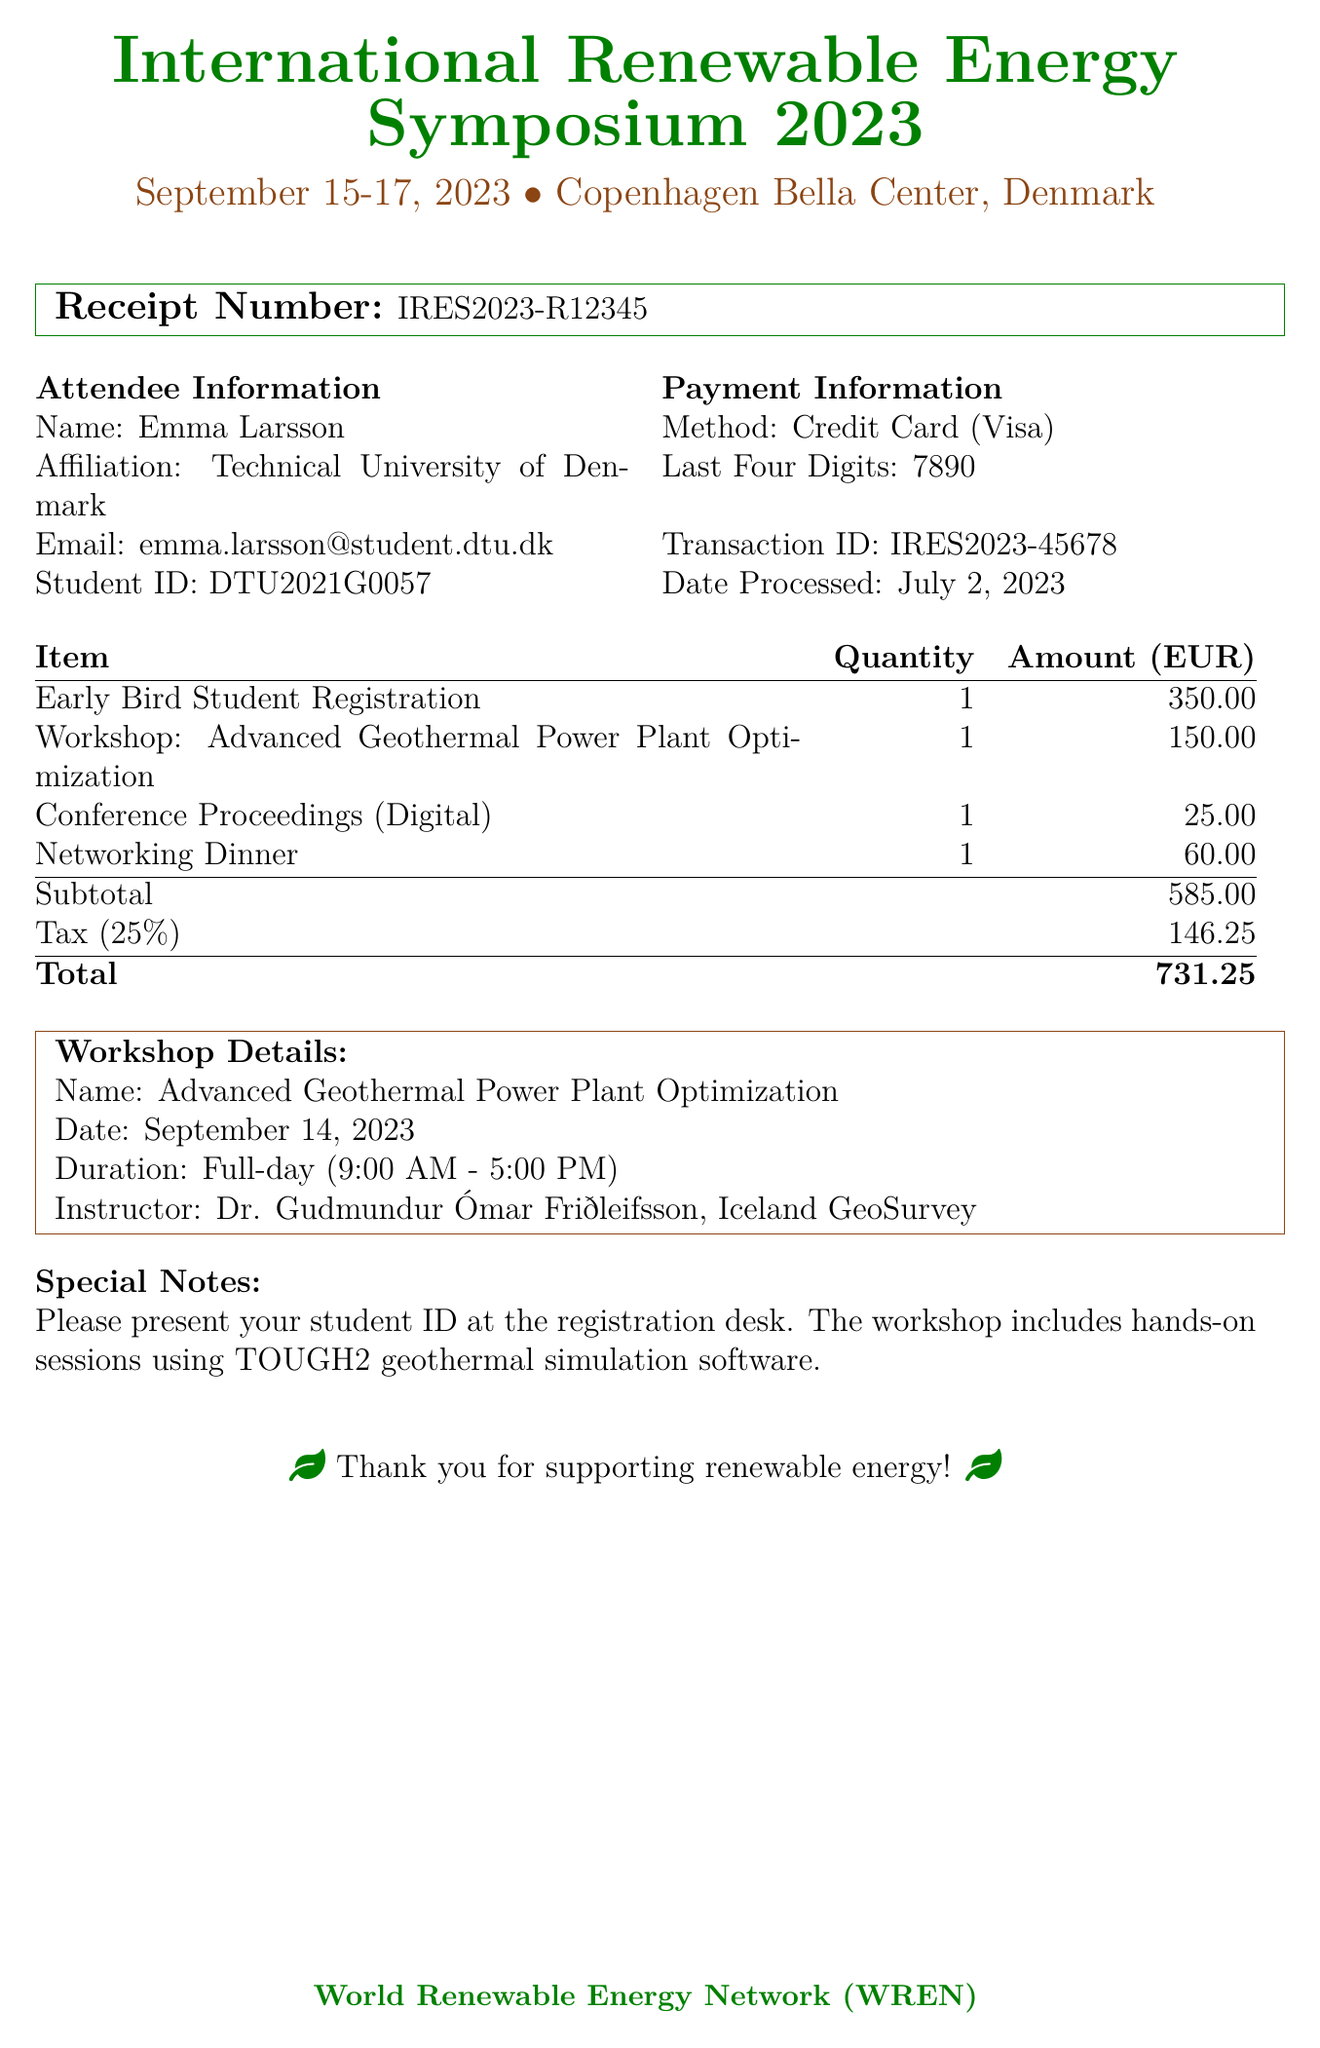what is the name of the symposium? The document specifies the event as the "International Renewable Energy Symposium 2023."
Answer: International Renewable Energy Symposium 2023 what is the date of the workshop? The document states that the workshop is scheduled for September 14, 2023.
Answer: September 14, 2023 who is the instructor of the workshop? The document mentions the instructor as "Dr. Gudmundur Ómar Friðleifsson, Iceland GeoSurvey."
Answer: Dr. Gudmundur Ómar Friðleifsson, Iceland GeoSurvey what is the total amount paid? The total amount is explicitly stated in the document as €731.25.
Answer: €731.25 what is the early bird student registration fee? The document lists the early bird student registration fee as €350.00.
Answer: €350.00 how many items are listed in the additional items section? The document includes two additional items: Conference Proceedings and Networking Dinner.
Answer: 2 what mode of payment was used for the registration? The document indicates that the payment method is a credit card.
Answer: Credit Card what is the tax rate applied to the registration fees? The document specifies the tax rate as 25%.
Answer: 25% what is mentioned in the special notes section? The special notes section advises to present the student ID at the registration desk and mentions the workshop sessions.
Answer: Please present your student ID at the registration desk. The workshop includes hands-on sessions using TOUGH2 geothermal simulation software 